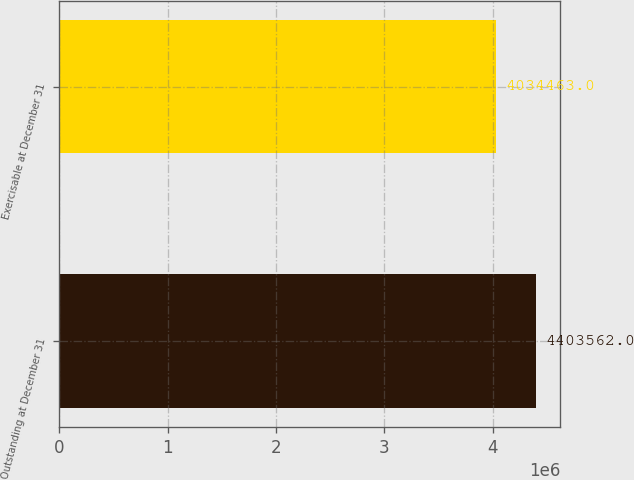Convert chart. <chart><loc_0><loc_0><loc_500><loc_500><bar_chart><fcel>Outstanding at December 31<fcel>Exercisable at December 31<nl><fcel>4.40356e+06<fcel>4.03446e+06<nl></chart> 